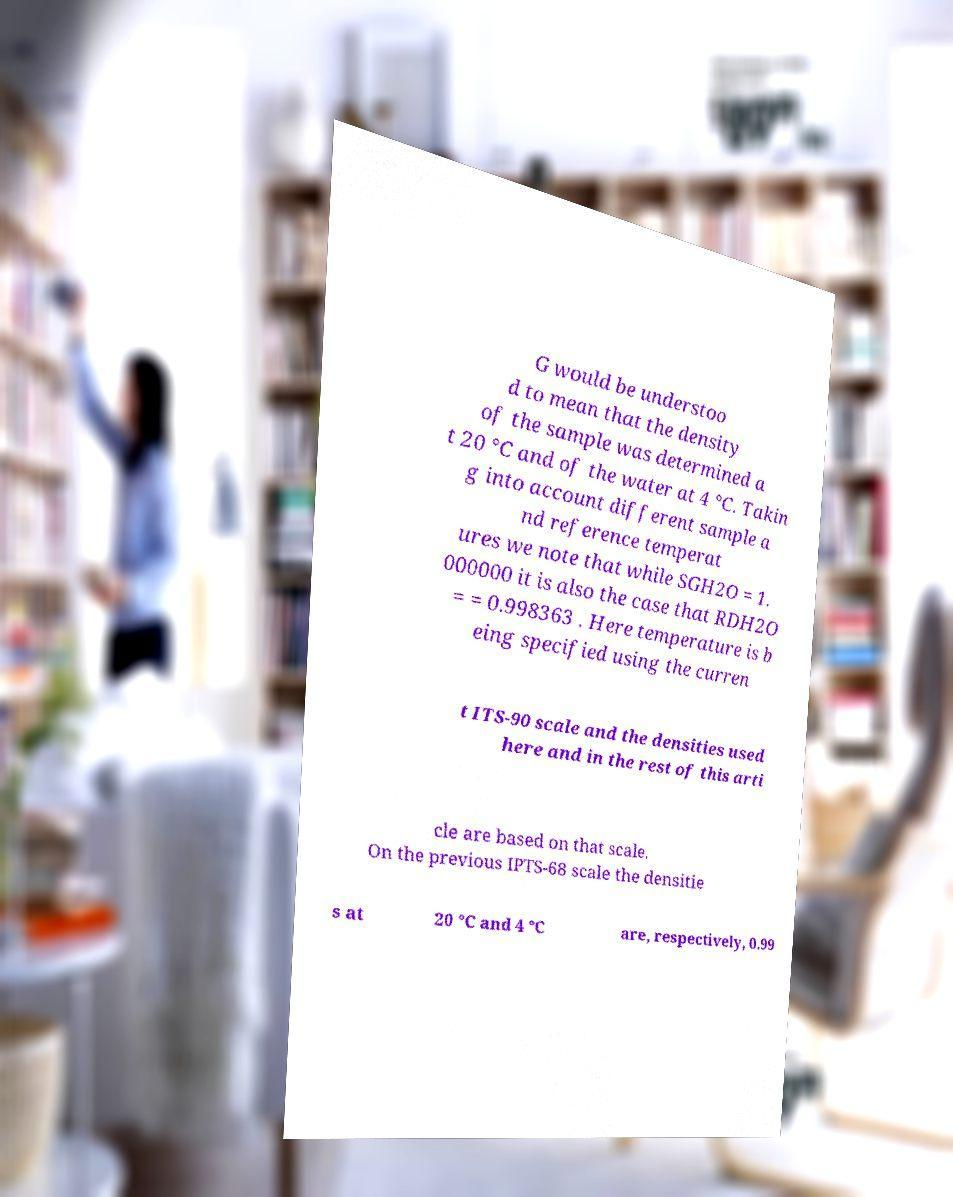For documentation purposes, I need the text within this image transcribed. Could you provide that? G would be understoo d to mean that the density of the sample was determined a t 20 °C and of the water at 4 °C. Takin g into account different sample a nd reference temperat ures we note that while SGH2O = 1. 000000 it is also the case that RDH2O = = 0.998363 . Here temperature is b eing specified using the curren t ITS-90 scale and the densities used here and in the rest of this arti cle are based on that scale. On the previous IPTS-68 scale the densitie s at 20 °C and 4 °C are, respectively, 0.99 